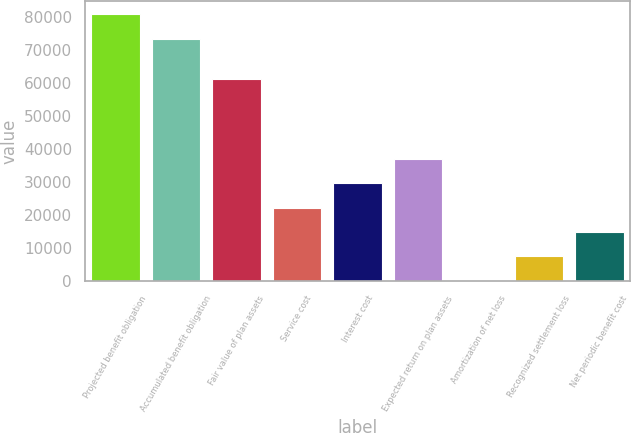<chart> <loc_0><loc_0><loc_500><loc_500><bar_chart><fcel>Projected benefit obligation<fcel>Accumulated benefit obligation<fcel>Fair value of plan assets<fcel>Service cost<fcel>Interest cost<fcel>Expected return on plan assets<fcel>Amortization of net loss<fcel>Recognized settlement loss<fcel>Net periodic benefit cost<nl><fcel>80916.5<fcel>73550<fcel>61362<fcel>22305.5<fcel>29672<fcel>37038.5<fcel>206<fcel>7572.5<fcel>14939<nl></chart> 